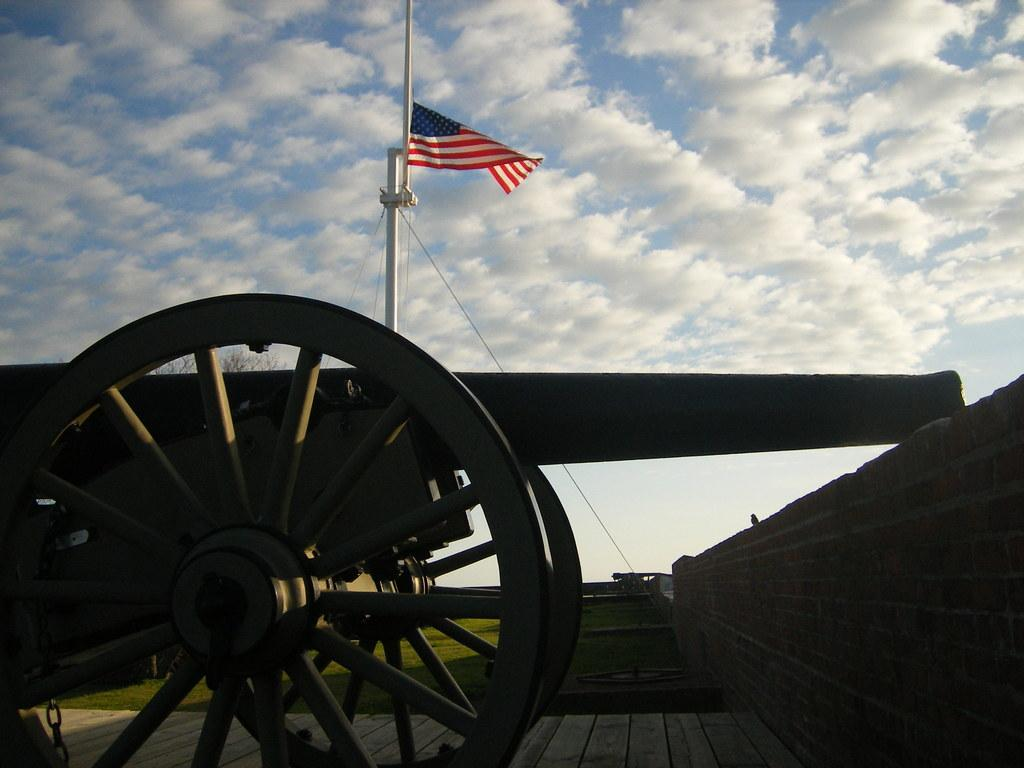What is the main object in the foreground of the image? There is a cannon in the foreground of the image. What is located on the right side of the image? There is a wall on the right side of the image. What can be seen in the background of the image? There is a flag and grassland visible in the background of the image. What is visible above the grassland in the image? The sky is visible in the background of the image. Where is the honey stored on the cannon in the image? There is no honey present in the image, and the cannon is not a storage container for honey. 